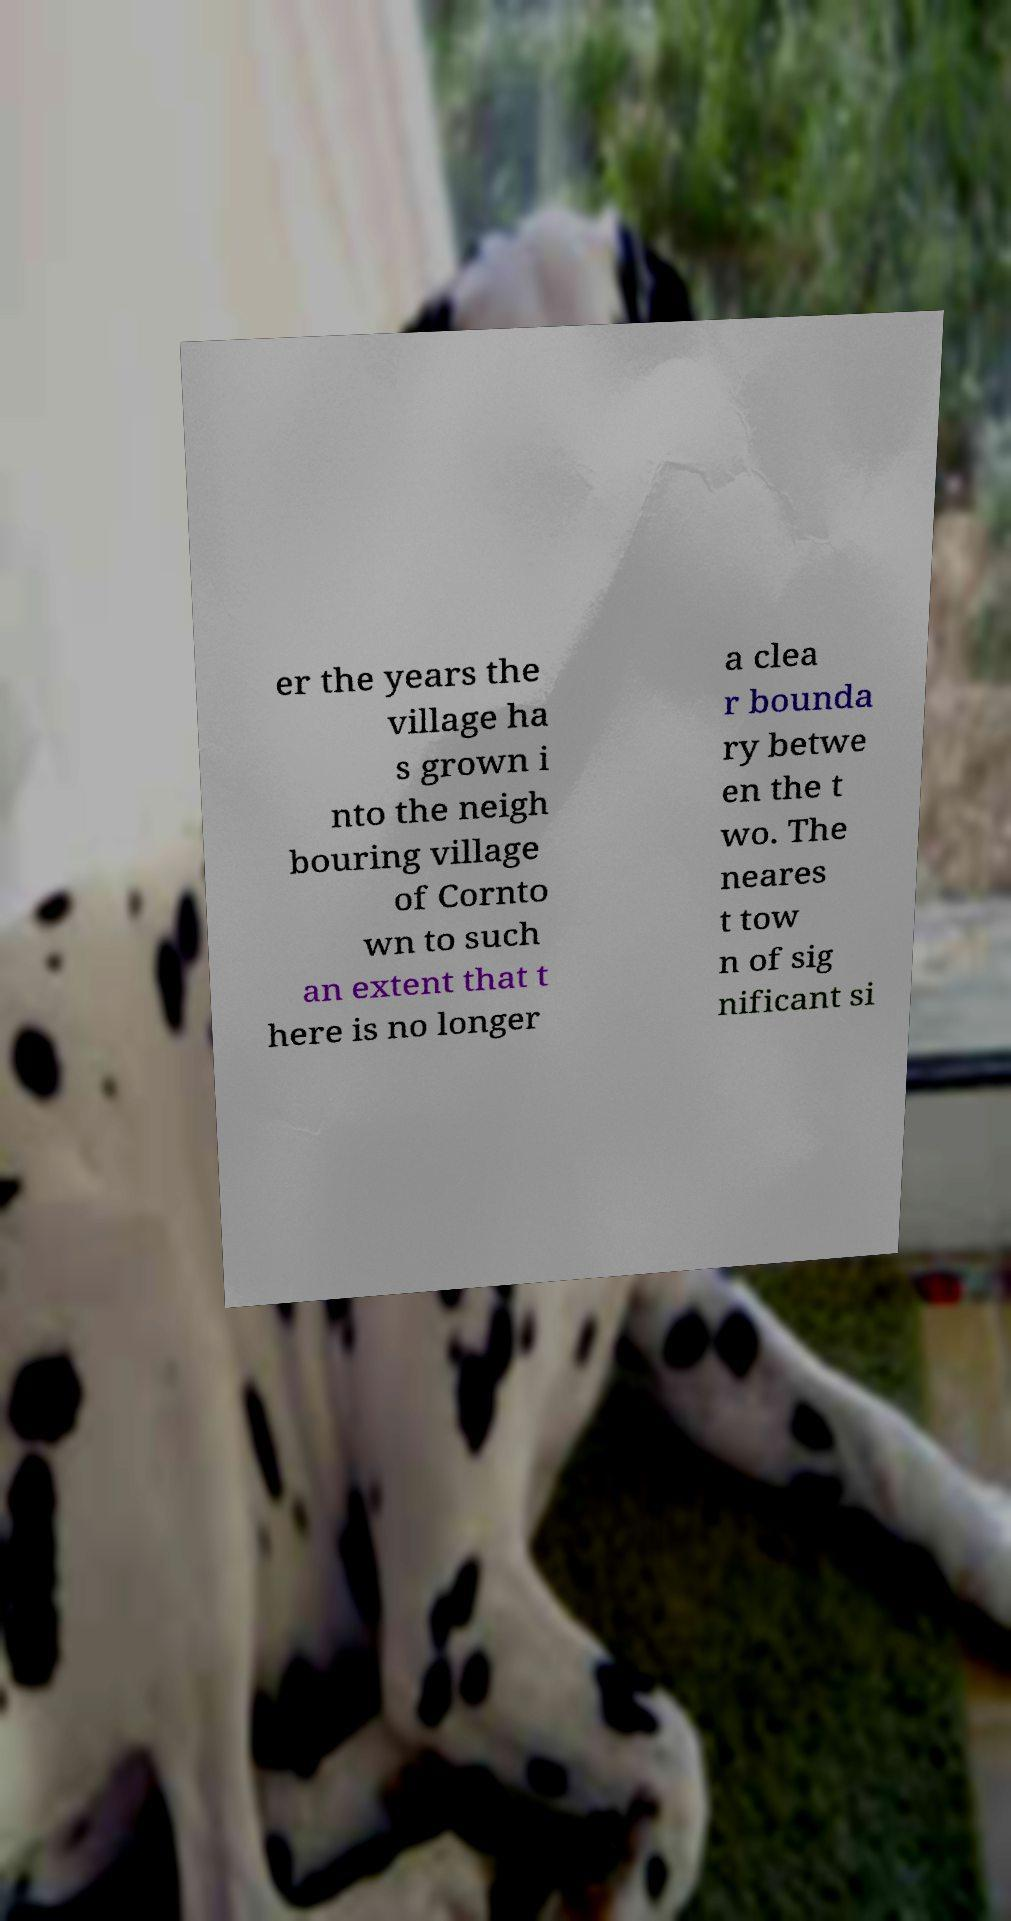Could you assist in decoding the text presented in this image and type it out clearly? er the years the village ha s grown i nto the neigh bouring village of Cornto wn to such an extent that t here is no longer a clea r bounda ry betwe en the t wo. The neares t tow n of sig nificant si 